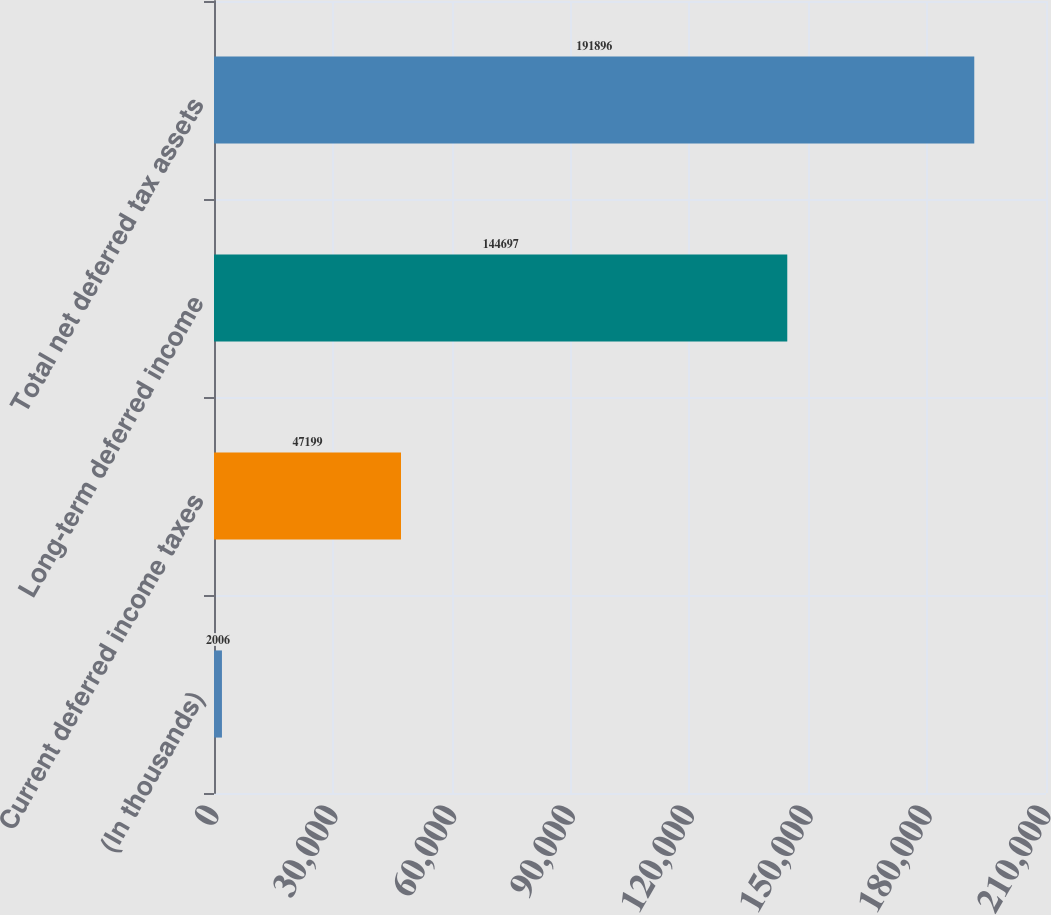Convert chart to OTSL. <chart><loc_0><loc_0><loc_500><loc_500><bar_chart><fcel>(In thousands)<fcel>Current deferred income taxes<fcel>Long-term deferred income<fcel>Total net deferred tax assets<nl><fcel>2006<fcel>47199<fcel>144697<fcel>191896<nl></chart> 